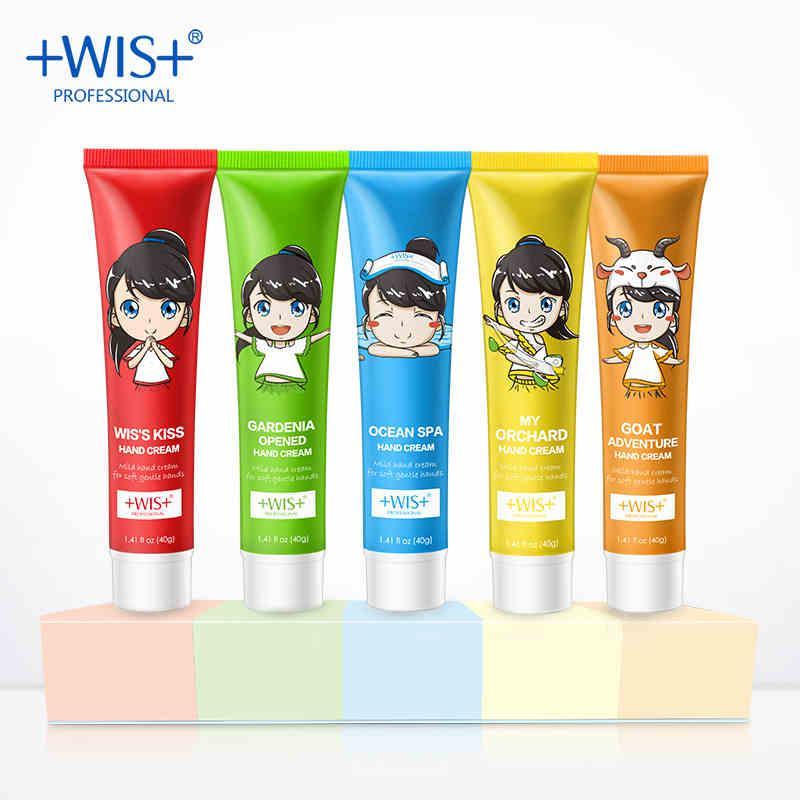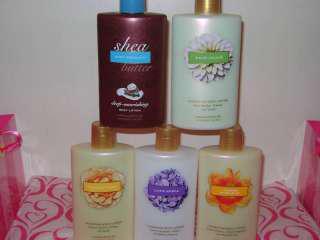The first image is the image on the left, the second image is the image on the right. Assess this claim about the two images: "The right image shows just two skincare items side-by-side.". Correct or not? Answer yes or no. No. The first image is the image on the left, the second image is the image on the right. For the images displayed, is the sentence "At least ten lotion-type products are shown in total." factually correct? Answer yes or no. Yes. 